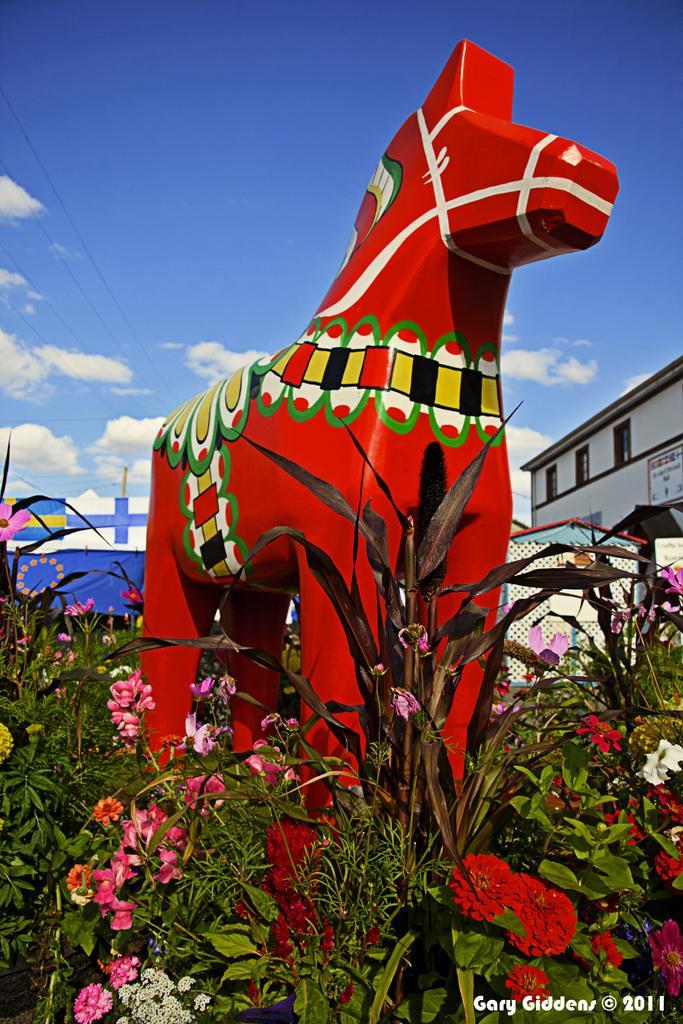How would you summarize this image in a sentence or two? In the picture we can see plants with flowers and in it we can see a huge horse sculpture which is red in color with designs on it and behind it, we can see a building which is blue in color and beside it also we can see a building with windows and in the background we can see the sky with clouds. 